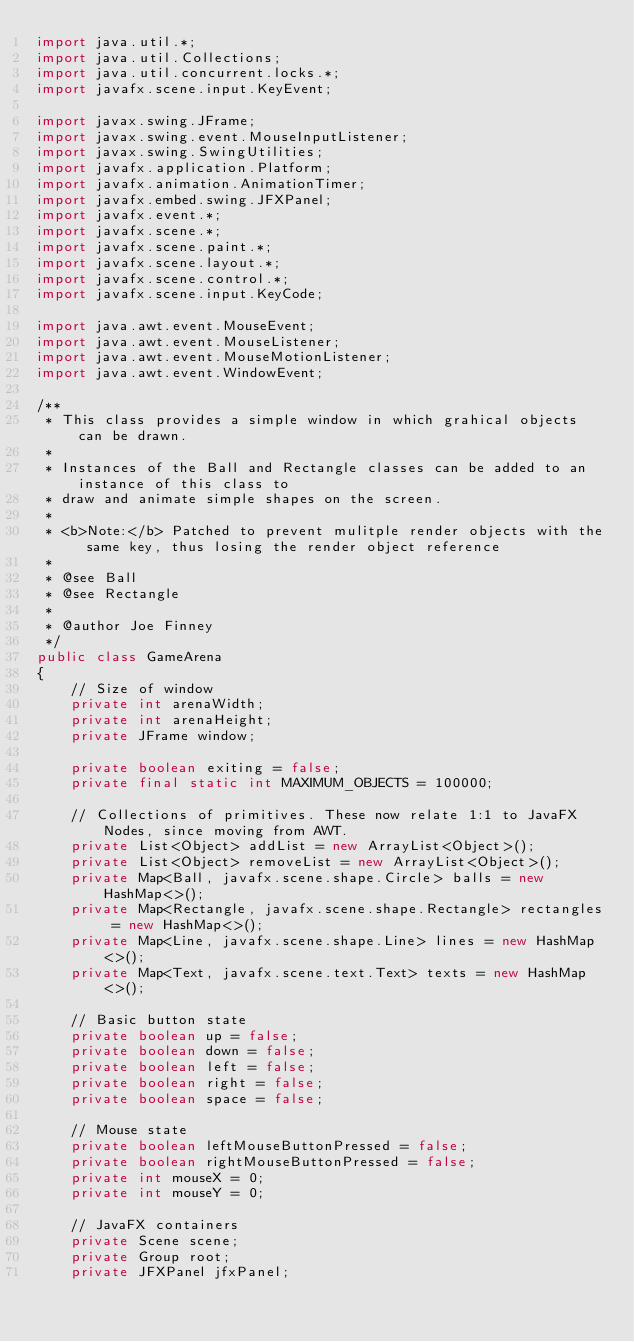<code> <loc_0><loc_0><loc_500><loc_500><_Java_>import java.util.*;
import java.util.Collections;
import java.util.concurrent.locks.*;
import javafx.scene.input.KeyEvent;

import javax.swing.JFrame;
import javax.swing.event.MouseInputListener;
import javax.swing.SwingUtilities;
import javafx.application.Platform;
import javafx.animation.AnimationTimer;
import javafx.embed.swing.JFXPanel;
import javafx.event.*;
import javafx.scene.*;
import javafx.scene.paint.*;
import javafx.scene.layout.*;
import javafx.scene.control.*;
import javafx.scene.input.KeyCode;

import java.awt.event.MouseEvent;
import java.awt.event.MouseListener;
import java.awt.event.MouseMotionListener;
import java.awt.event.WindowEvent;

/**
 * This class provides a simple window in which grahical objects can be drawn. 
 *
 * Instances of the Ball and Rectangle classes can be added to an instance of this class to
 * draw and animate simple shapes on the screen. 
 *
 * <b>Note:</b> Patched to prevent mulitple render objects with the same key, thus losing the render object reference
 *
 * @see Ball
 * @see Rectangle
 *
 * @author Joe Finney
 */
public class GameArena
{
	// Size of window
	private int arenaWidth;
	private int arenaHeight;
    private JFrame window;

	private boolean exiting = false;
    private final static int MAXIMUM_OBJECTS = 100000;

    // Collections of primitives. These now relate 1:1 to JavaFX Nodes, since moving from AWT.
    private List<Object> addList = new ArrayList<Object>();
    private List<Object> removeList = new ArrayList<Object>();
    private Map<Ball, javafx.scene.shape.Circle> balls = new HashMap<>();
    private Map<Rectangle, javafx.scene.shape.Rectangle> rectangles = new HashMap<>();
    private Map<Line, javafx.scene.shape.Line> lines = new HashMap<>();
    private Map<Text, javafx.scene.text.Text> texts = new HashMap<>();

    // Basic button state
	private boolean up = false;
	private boolean down = false;
	private boolean left = false;
	private boolean right = false;
	private boolean space = false;

    // Mouse state
    private boolean leftMouseButtonPressed = false;
    private boolean rightMouseButtonPressed = false;
    private int mouseX = 0;
    private int mouseY = 0;

    // JavaFX containers
    private Scene scene;
    private Group root;
    private JFXPanel jfxPanel;
</code> 